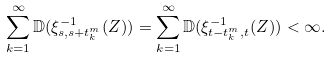<formula> <loc_0><loc_0><loc_500><loc_500>\sum _ { k = 1 } ^ { \infty } \mathbb { D } ( \xi _ { s , s + t _ { k } ^ { m } } ^ { - 1 } ( Z ) ) = \sum _ { k = 1 } ^ { \infty } \mathbb { D } ( \xi _ { t - t _ { k } ^ { m } , t } ^ { - 1 } ( Z ) ) < \infty .</formula> 